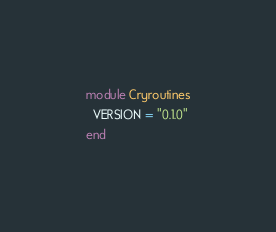Convert code to text. <code><loc_0><loc_0><loc_500><loc_500><_Crystal_>module Cryroutines
  VERSION = "0.1.0"
end
</code> 